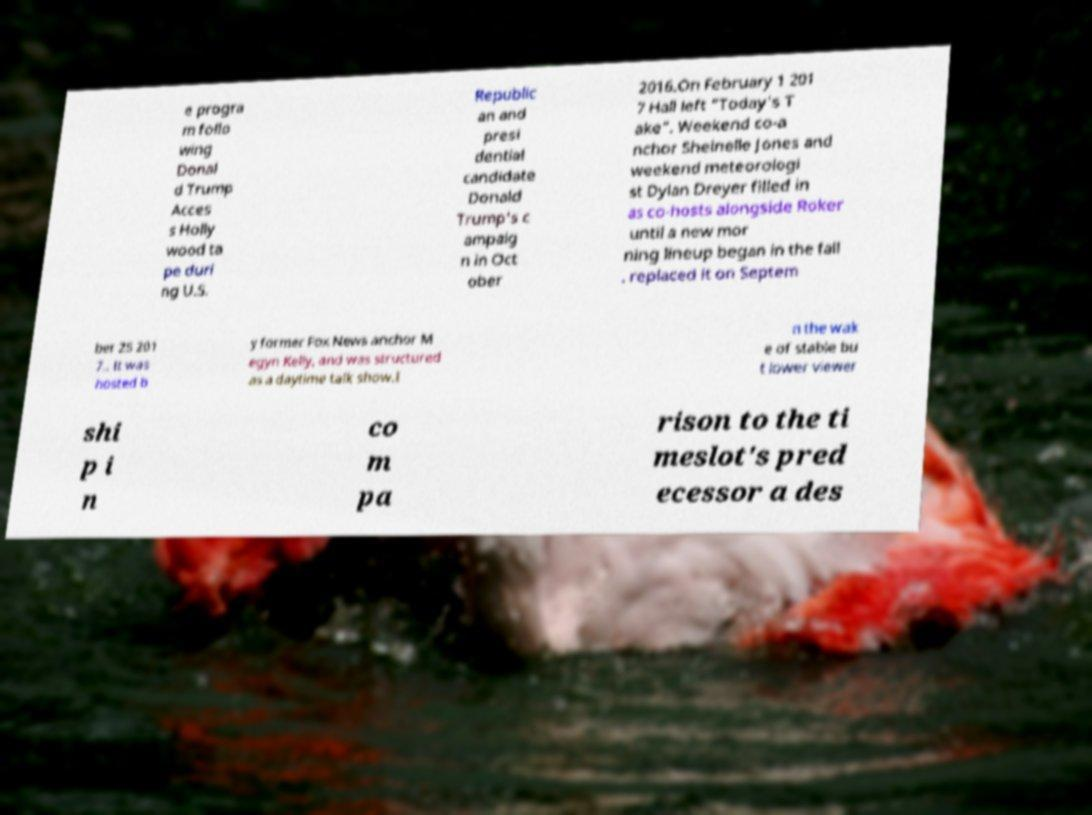There's text embedded in this image that I need extracted. Can you transcribe it verbatim? e progra m follo wing Donal d Trump Acces s Holly wood ta pe duri ng U.S. Republic an and presi dential candidate Donald Trump's c ampaig n in Oct ober 2016.On February 1 201 7 Hall left "Today's T ake". Weekend co-a nchor Sheinelle Jones and weekend meteorologi st Dylan Dreyer filled in as co-hosts alongside Roker until a new mor ning lineup began in the fall . replaced it on Septem ber 25 201 7.. It was hosted b y former Fox News anchor M egyn Kelly, and was structured as a daytime talk show.I n the wak e of stable bu t lower viewer shi p i n co m pa rison to the ti meslot's pred ecessor a des 